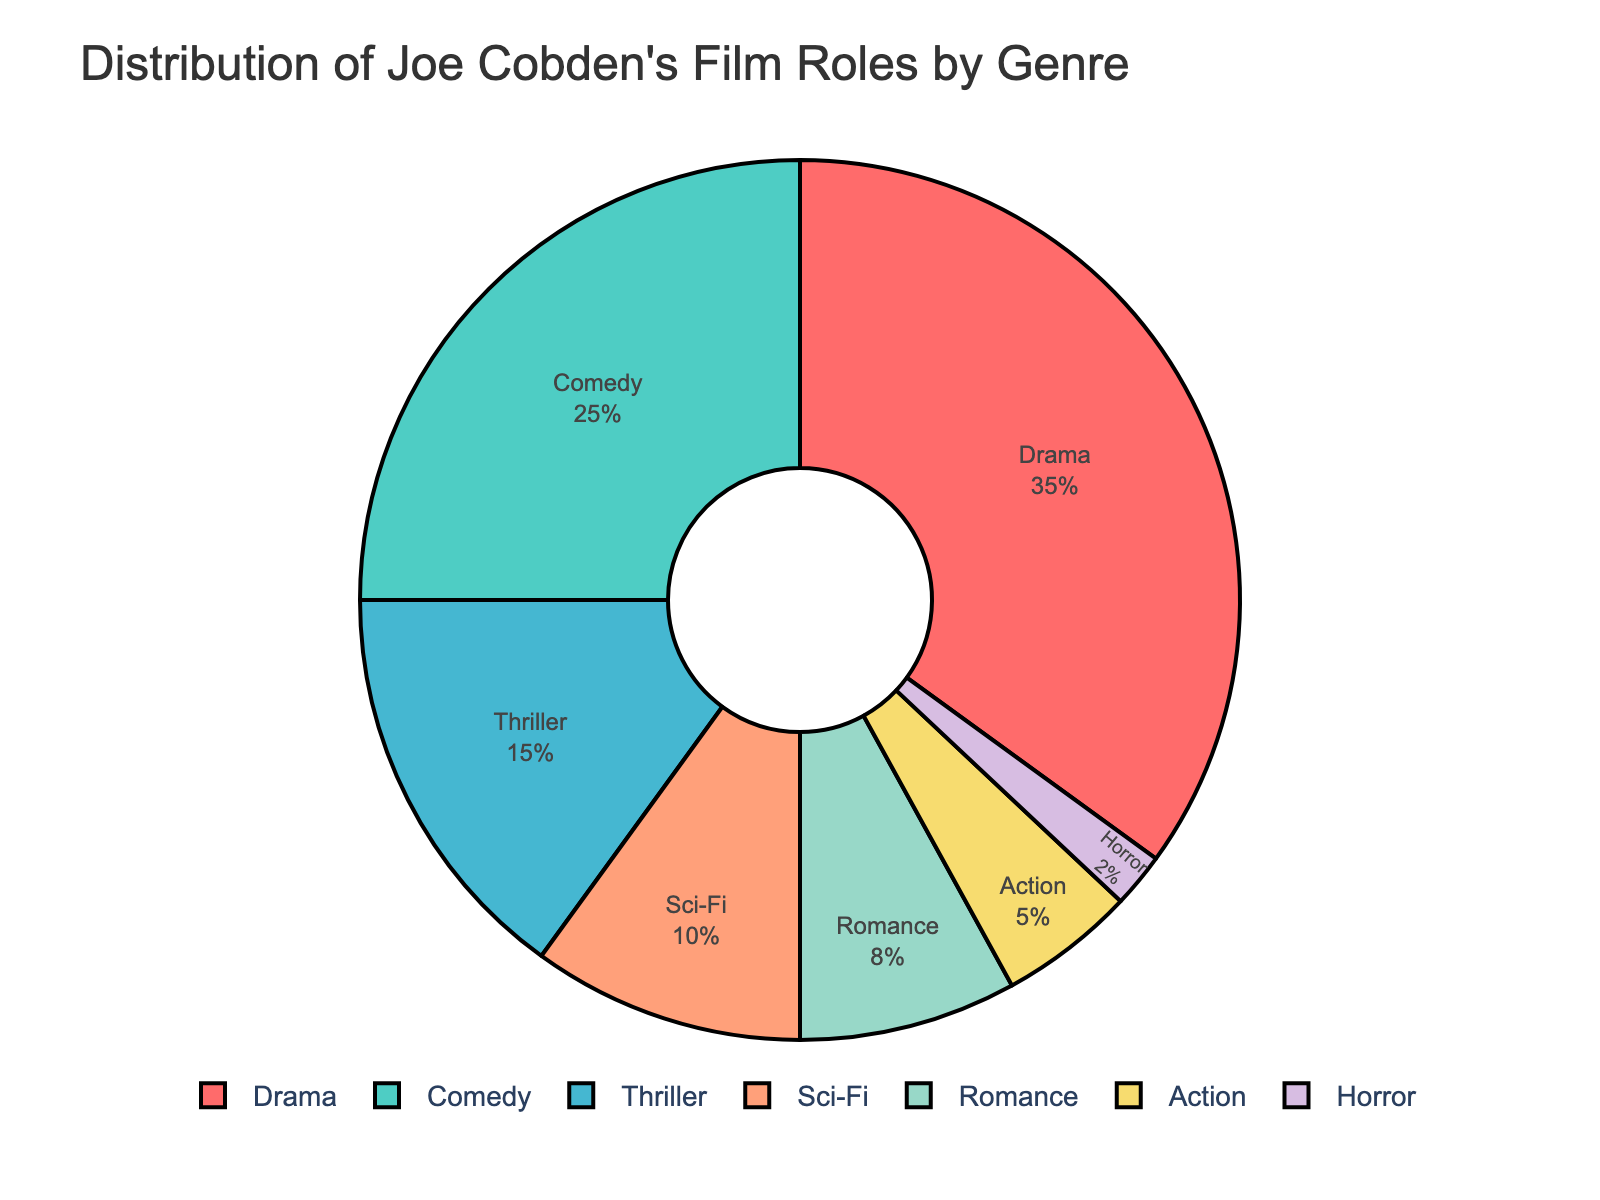What percentage of Joe Cobden's film roles fall into the Comedy genre? Identify the section labeled "Comedy" in the pie chart and read the percentage associated with it.
Answer: 25% Which genre has the least representation in Joe Cobden's film roles? Find the smallest section in the pie chart and note the genre labeled on it.
Answer: Horror How much more frequent are Joe Cobden's roles in Drama compared to Sci-Fi? Identify the percentages for Drama and Sci-Fi, then calculate the difference: 35% - 10%.
Answer: 25% What is the combined percentage of Joe Cobden's roles in Thriller and Action genres? Identify the percentages for Thriller and Action, then add them together: 15% + 5%.
Answer: 20% Which genre has a larger percentage of roles, Romance or Sci-Fi? Compare the percentages associated with Romance and Sci-Fi in the pie chart: 8% vs 10%.
Answer: Sci-Fi What is the third most common genre in Joe Cobden's film roles? Rank the percentages from highest to lowest and find the third largest: Drama (35%), Comedy (25%), Thriller (15%).
Answer: Thriller What is the difference in percentage between Joe Cobden's roles in Comedy and Horror genres? Identify the percentages for Comedy and Horror, then calculate the difference: 25% - 2%.
Answer: 23% What's the total percentage of Joe Cobden's roles in genres other than Drama and Comedy? Subtract the combined percentage of Drama and Comedy from 100%: 100% - (35% + 25%).
Answer: 40% Which genre's section is represented in red on the pie chart? Refer to the custom color palette and identify which genre corresponds to the red section (#FF6B6B).
Answer: Drama Between Romance and Horror, which genre occupies a smaller section of the pie chart? Compare the sizes of the sections labeled Romance and Horror: 8% vs 2%.
Answer: Horror 